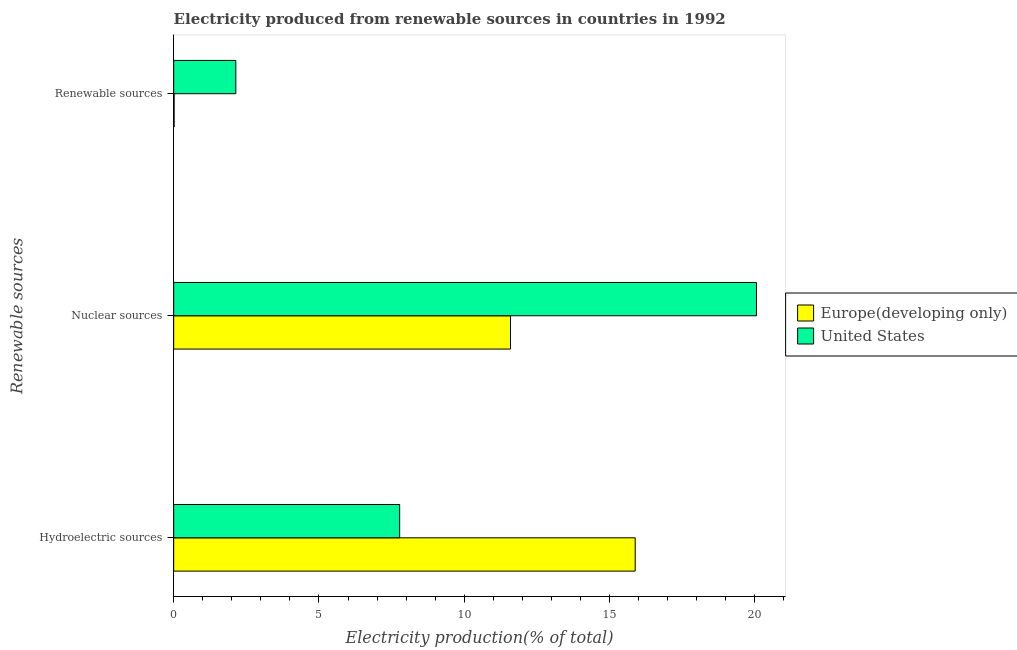Are the number of bars per tick equal to the number of legend labels?
Keep it short and to the point. Yes. Are the number of bars on each tick of the Y-axis equal?
Make the answer very short. Yes. What is the label of the 1st group of bars from the top?
Provide a short and direct response. Renewable sources. What is the percentage of electricity produced by renewable sources in Europe(developing only)?
Ensure brevity in your answer.  0.02. Across all countries, what is the maximum percentage of electricity produced by nuclear sources?
Your answer should be very brief. 20.06. Across all countries, what is the minimum percentage of electricity produced by renewable sources?
Offer a terse response. 0.02. In which country was the percentage of electricity produced by nuclear sources maximum?
Make the answer very short. United States. In which country was the percentage of electricity produced by nuclear sources minimum?
Give a very brief answer. Europe(developing only). What is the total percentage of electricity produced by renewable sources in the graph?
Your answer should be very brief. 2.15. What is the difference between the percentage of electricity produced by renewable sources in Europe(developing only) and that in United States?
Provide a succinct answer. -2.12. What is the difference between the percentage of electricity produced by renewable sources in United States and the percentage of electricity produced by nuclear sources in Europe(developing only)?
Your response must be concise. -9.45. What is the average percentage of electricity produced by renewable sources per country?
Ensure brevity in your answer.  1.08. What is the difference between the percentage of electricity produced by nuclear sources and percentage of electricity produced by hydroelectric sources in Europe(developing only)?
Keep it short and to the point. -4.29. What is the ratio of the percentage of electricity produced by nuclear sources in Europe(developing only) to that in United States?
Offer a very short reply. 0.58. What is the difference between the highest and the second highest percentage of electricity produced by nuclear sources?
Your answer should be very brief. 8.47. What is the difference between the highest and the lowest percentage of electricity produced by hydroelectric sources?
Provide a short and direct response. 8.11. In how many countries, is the percentage of electricity produced by hydroelectric sources greater than the average percentage of electricity produced by hydroelectric sources taken over all countries?
Provide a short and direct response. 1. Is the sum of the percentage of electricity produced by nuclear sources in United States and Europe(developing only) greater than the maximum percentage of electricity produced by hydroelectric sources across all countries?
Offer a very short reply. Yes. What does the 1st bar from the top in Hydroelectric sources represents?
Your answer should be compact. United States. What does the 2nd bar from the bottom in Renewable sources represents?
Your response must be concise. United States. Does the graph contain grids?
Your response must be concise. No. How are the legend labels stacked?
Your answer should be very brief. Vertical. What is the title of the graph?
Your response must be concise. Electricity produced from renewable sources in countries in 1992. Does "Upper middle income" appear as one of the legend labels in the graph?
Ensure brevity in your answer.  No. What is the label or title of the Y-axis?
Ensure brevity in your answer.  Renewable sources. What is the Electricity production(% of total) in Europe(developing only) in Hydroelectric sources?
Your response must be concise. 15.88. What is the Electricity production(% of total) in United States in Hydroelectric sources?
Ensure brevity in your answer.  7.78. What is the Electricity production(% of total) in Europe(developing only) in Nuclear sources?
Provide a short and direct response. 11.59. What is the Electricity production(% of total) of United States in Nuclear sources?
Provide a short and direct response. 20.06. What is the Electricity production(% of total) of Europe(developing only) in Renewable sources?
Make the answer very short. 0.02. What is the Electricity production(% of total) in United States in Renewable sources?
Keep it short and to the point. 2.14. Across all Renewable sources, what is the maximum Electricity production(% of total) in Europe(developing only)?
Provide a succinct answer. 15.88. Across all Renewable sources, what is the maximum Electricity production(% of total) of United States?
Make the answer very short. 20.06. Across all Renewable sources, what is the minimum Electricity production(% of total) of Europe(developing only)?
Your response must be concise. 0.02. Across all Renewable sources, what is the minimum Electricity production(% of total) in United States?
Your answer should be very brief. 2.14. What is the total Electricity production(% of total) in Europe(developing only) in the graph?
Offer a very short reply. 27.49. What is the total Electricity production(% of total) of United States in the graph?
Your response must be concise. 29.97. What is the difference between the Electricity production(% of total) in Europe(developing only) in Hydroelectric sources and that in Nuclear sources?
Your answer should be very brief. 4.29. What is the difference between the Electricity production(% of total) in United States in Hydroelectric sources and that in Nuclear sources?
Provide a short and direct response. -12.28. What is the difference between the Electricity production(% of total) in Europe(developing only) in Hydroelectric sources and that in Renewable sources?
Offer a terse response. 15.87. What is the difference between the Electricity production(% of total) in United States in Hydroelectric sources and that in Renewable sources?
Offer a terse response. 5.64. What is the difference between the Electricity production(% of total) of Europe(developing only) in Nuclear sources and that in Renewable sources?
Make the answer very short. 11.58. What is the difference between the Electricity production(% of total) of United States in Nuclear sources and that in Renewable sources?
Your answer should be very brief. 17.92. What is the difference between the Electricity production(% of total) in Europe(developing only) in Hydroelectric sources and the Electricity production(% of total) in United States in Nuclear sources?
Make the answer very short. -4.17. What is the difference between the Electricity production(% of total) in Europe(developing only) in Hydroelectric sources and the Electricity production(% of total) in United States in Renewable sources?
Provide a short and direct response. 13.74. What is the difference between the Electricity production(% of total) of Europe(developing only) in Nuclear sources and the Electricity production(% of total) of United States in Renewable sources?
Ensure brevity in your answer.  9.45. What is the average Electricity production(% of total) in Europe(developing only) per Renewable sources?
Offer a very short reply. 9.16. What is the average Electricity production(% of total) in United States per Renewable sources?
Make the answer very short. 9.99. What is the difference between the Electricity production(% of total) in Europe(developing only) and Electricity production(% of total) in United States in Hydroelectric sources?
Make the answer very short. 8.11. What is the difference between the Electricity production(% of total) in Europe(developing only) and Electricity production(% of total) in United States in Nuclear sources?
Keep it short and to the point. -8.47. What is the difference between the Electricity production(% of total) of Europe(developing only) and Electricity production(% of total) of United States in Renewable sources?
Provide a succinct answer. -2.12. What is the ratio of the Electricity production(% of total) in Europe(developing only) in Hydroelectric sources to that in Nuclear sources?
Offer a terse response. 1.37. What is the ratio of the Electricity production(% of total) in United States in Hydroelectric sources to that in Nuclear sources?
Offer a very short reply. 0.39. What is the ratio of the Electricity production(% of total) in Europe(developing only) in Hydroelectric sources to that in Renewable sources?
Provide a succinct answer. 982.26. What is the ratio of the Electricity production(% of total) of United States in Hydroelectric sources to that in Renewable sources?
Provide a succinct answer. 3.64. What is the ratio of the Electricity production(% of total) in Europe(developing only) in Nuclear sources to that in Renewable sources?
Provide a succinct answer. 716.82. What is the ratio of the Electricity production(% of total) of United States in Nuclear sources to that in Renewable sources?
Ensure brevity in your answer.  9.38. What is the difference between the highest and the second highest Electricity production(% of total) in Europe(developing only)?
Your answer should be very brief. 4.29. What is the difference between the highest and the second highest Electricity production(% of total) in United States?
Give a very brief answer. 12.28. What is the difference between the highest and the lowest Electricity production(% of total) in Europe(developing only)?
Provide a succinct answer. 15.87. What is the difference between the highest and the lowest Electricity production(% of total) in United States?
Give a very brief answer. 17.92. 